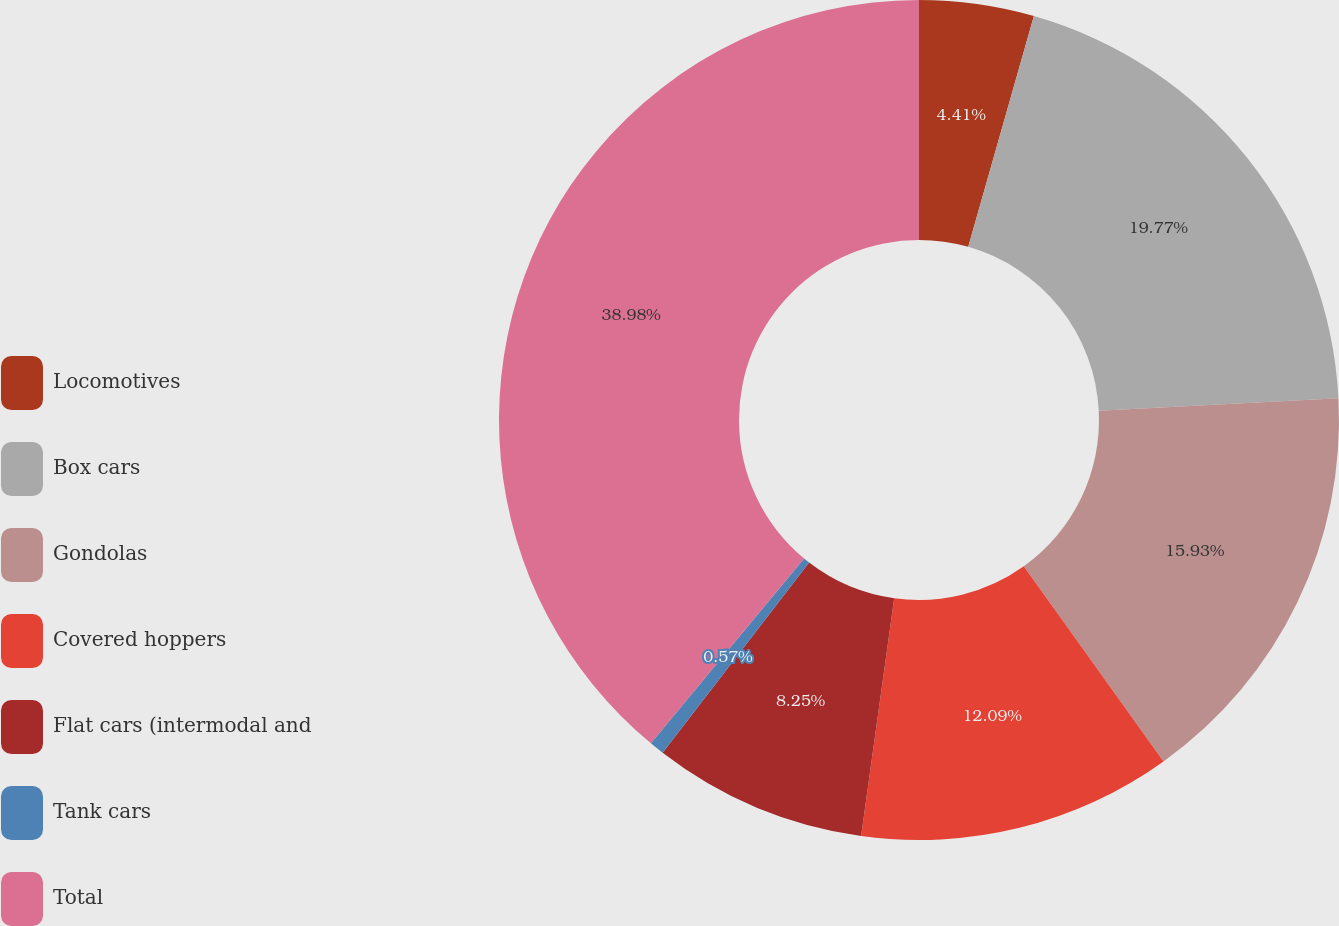<chart> <loc_0><loc_0><loc_500><loc_500><pie_chart><fcel>Locomotives<fcel>Box cars<fcel>Gondolas<fcel>Covered hoppers<fcel>Flat cars (intermodal and<fcel>Tank cars<fcel>Total<nl><fcel>4.41%<fcel>19.77%<fcel>15.93%<fcel>12.09%<fcel>8.25%<fcel>0.57%<fcel>38.98%<nl></chart> 